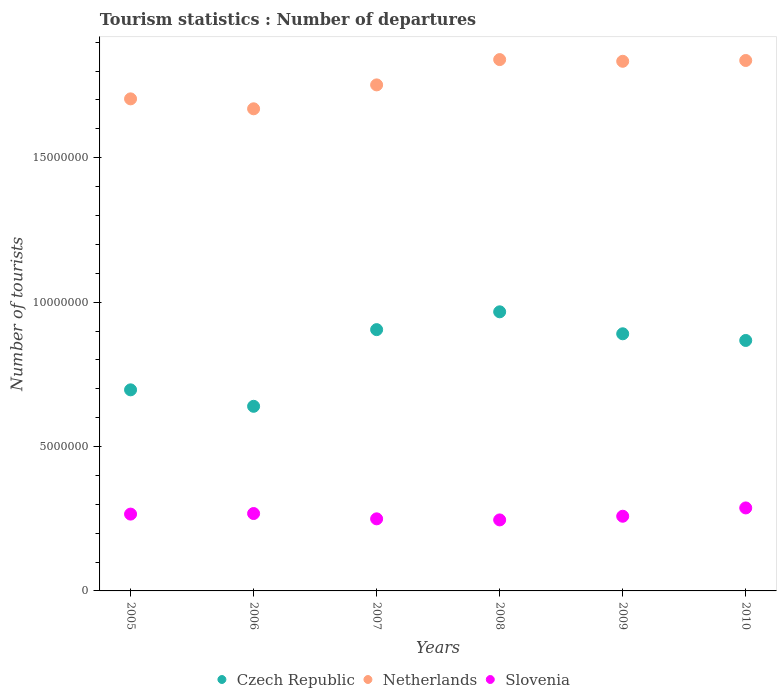How many different coloured dotlines are there?
Your response must be concise. 3. Is the number of dotlines equal to the number of legend labels?
Offer a terse response. Yes. What is the number of tourist departures in Netherlands in 2007?
Provide a succinct answer. 1.75e+07. Across all years, what is the maximum number of tourist departures in Czech Republic?
Make the answer very short. 9.66e+06. Across all years, what is the minimum number of tourist departures in Czech Republic?
Offer a terse response. 6.39e+06. In which year was the number of tourist departures in Czech Republic maximum?
Your answer should be compact. 2008. In which year was the number of tourist departures in Czech Republic minimum?
Ensure brevity in your answer.  2006. What is the total number of tourist departures in Czech Republic in the graph?
Keep it short and to the point. 4.96e+07. What is the difference between the number of tourist departures in Czech Republic in 2006 and that in 2008?
Give a very brief answer. -3.27e+06. What is the difference between the number of tourist departures in Czech Republic in 2005 and the number of tourist departures in Netherlands in 2010?
Ensure brevity in your answer.  -1.14e+07. What is the average number of tourist departures in Slovenia per year?
Your answer should be very brief. 2.63e+06. In the year 2007, what is the difference between the number of tourist departures in Netherlands and number of tourist departures in Czech Republic?
Give a very brief answer. 8.48e+06. What is the ratio of the number of tourist departures in Slovenia in 2009 to that in 2010?
Offer a very short reply. 0.9. Is the number of tourist departures in Slovenia in 2008 less than that in 2010?
Your response must be concise. Yes. Is the difference between the number of tourist departures in Netherlands in 2007 and 2010 greater than the difference between the number of tourist departures in Czech Republic in 2007 and 2010?
Your answer should be compact. No. What is the difference between the highest and the second highest number of tourist departures in Slovenia?
Keep it short and to the point. 1.94e+05. What is the difference between the highest and the lowest number of tourist departures in Czech Republic?
Provide a succinct answer. 3.27e+06. Does the number of tourist departures in Slovenia monotonically increase over the years?
Make the answer very short. No. Is the number of tourist departures in Slovenia strictly greater than the number of tourist departures in Czech Republic over the years?
Keep it short and to the point. No. Is the number of tourist departures in Netherlands strictly less than the number of tourist departures in Czech Republic over the years?
Give a very brief answer. No. How many years are there in the graph?
Ensure brevity in your answer.  6. What is the difference between two consecutive major ticks on the Y-axis?
Give a very brief answer. 5.00e+06. Where does the legend appear in the graph?
Keep it short and to the point. Bottom center. What is the title of the graph?
Provide a short and direct response. Tourism statistics : Number of departures. What is the label or title of the X-axis?
Offer a very short reply. Years. What is the label or title of the Y-axis?
Offer a very short reply. Number of tourists. What is the Number of tourists in Czech Republic in 2005?
Ensure brevity in your answer.  6.96e+06. What is the Number of tourists in Netherlands in 2005?
Offer a very short reply. 1.70e+07. What is the Number of tourists in Slovenia in 2005?
Ensure brevity in your answer.  2.66e+06. What is the Number of tourists of Czech Republic in 2006?
Provide a short and direct response. 6.39e+06. What is the Number of tourists of Netherlands in 2006?
Keep it short and to the point. 1.67e+07. What is the Number of tourists of Slovenia in 2006?
Offer a very short reply. 2.68e+06. What is the Number of tourists of Czech Republic in 2007?
Provide a short and direct response. 9.05e+06. What is the Number of tourists of Netherlands in 2007?
Ensure brevity in your answer.  1.75e+07. What is the Number of tourists of Slovenia in 2007?
Keep it short and to the point. 2.50e+06. What is the Number of tourists of Czech Republic in 2008?
Ensure brevity in your answer.  9.66e+06. What is the Number of tourists in Netherlands in 2008?
Provide a succinct answer. 1.84e+07. What is the Number of tourists in Slovenia in 2008?
Your response must be concise. 2.46e+06. What is the Number of tourists in Czech Republic in 2009?
Your answer should be compact. 8.90e+06. What is the Number of tourists in Netherlands in 2009?
Offer a very short reply. 1.83e+07. What is the Number of tourists of Slovenia in 2009?
Offer a very short reply. 2.59e+06. What is the Number of tourists of Czech Republic in 2010?
Your answer should be compact. 8.67e+06. What is the Number of tourists of Netherlands in 2010?
Offer a very short reply. 1.84e+07. What is the Number of tourists of Slovenia in 2010?
Provide a short and direct response. 2.87e+06. Across all years, what is the maximum Number of tourists of Czech Republic?
Make the answer very short. 9.66e+06. Across all years, what is the maximum Number of tourists of Netherlands?
Offer a very short reply. 1.84e+07. Across all years, what is the maximum Number of tourists of Slovenia?
Keep it short and to the point. 2.87e+06. Across all years, what is the minimum Number of tourists of Czech Republic?
Offer a very short reply. 6.39e+06. Across all years, what is the minimum Number of tourists in Netherlands?
Give a very brief answer. 1.67e+07. Across all years, what is the minimum Number of tourists in Slovenia?
Make the answer very short. 2.46e+06. What is the total Number of tourists in Czech Republic in the graph?
Your response must be concise. 4.96e+07. What is the total Number of tourists of Netherlands in the graph?
Provide a short and direct response. 1.06e+08. What is the total Number of tourists in Slovenia in the graph?
Keep it short and to the point. 1.58e+07. What is the difference between the Number of tourists in Czech Republic in 2005 and that in 2006?
Provide a succinct answer. 5.70e+05. What is the difference between the Number of tourists of Netherlands in 2005 and that in 2006?
Ensure brevity in your answer.  3.44e+05. What is the difference between the Number of tourists in Czech Republic in 2005 and that in 2007?
Your response must be concise. -2.08e+06. What is the difference between the Number of tourists of Netherlands in 2005 and that in 2007?
Offer a terse response. -4.84e+05. What is the difference between the Number of tourists of Slovenia in 2005 and that in 2007?
Make the answer very short. 1.64e+05. What is the difference between the Number of tourists in Czech Republic in 2005 and that in 2008?
Your response must be concise. -2.70e+06. What is the difference between the Number of tourists in Netherlands in 2005 and that in 2008?
Your response must be concise. -1.36e+06. What is the difference between the Number of tourists in Slovenia in 2005 and that in 2008?
Offer a terse response. 2.01e+05. What is the difference between the Number of tourists in Czech Republic in 2005 and that in 2009?
Ensure brevity in your answer.  -1.94e+06. What is the difference between the Number of tourists in Netherlands in 2005 and that in 2009?
Your answer should be very brief. -1.30e+06. What is the difference between the Number of tourists of Slovenia in 2005 and that in 2009?
Offer a terse response. 7.40e+04. What is the difference between the Number of tourists in Czech Republic in 2005 and that in 2010?
Provide a short and direct response. -1.71e+06. What is the difference between the Number of tourists of Netherlands in 2005 and that in 2010?
Keep it short and to the point. -1.33e+06. What is the difference between the Number of tourists in Slovenia in 2005 and that in 2010?
Provide a short and direct response. -2.14e+05. What is the difference between the Number of tourists of Czech Republic in 2006 and that in 2007?
Ensure brevity in your answer.  -2.66e+06. What is the difference between the Number of tourists in Netherlands in 2006 and that in 2007?
Keep it short and to the point. -8.28e+05. What is the difference between the Number of tourists of Slovenia in 2006 and that in 2007?
Give a very brief answer. 1.84e+05. What is the difference between the Number of tourists of Czech Republic in 2006 and that in 2008?
Offer a very short reply. -3.27e+06. What is the difference between the Number of tourists of Netherlands in 2006 and that in 2008?
Your answer should be compact. -1.70e+06. What is the difference between the Number of tourists in Slovenia in 2006 and that in 2008?
Keep it short and to the point. 2.21e+05. What is the difference between the Number of tourists of Czech Republic in 2006 and that in 2009?
Your answer should be very brief. -2.51e+06. What is the difference between the Number of tourists in Netherlands in 2006 and that in 2009?
Ensure brevity in your answer.  -1.64e+06. What is the difference between the Number of tourists of Slovenia in 2006 and that in 2009?
Ensure brevity in your answer.  9.40e+04. What is the difference between the Number of tourists of Czech Republic in 2006 and that in 2010?
Your answer should be compact. -2.28e+06. What is the difference between the Number of tourists in Netherlands in 2006 and that in 2010?
Keep it short and to the point. -1.67e+06. What is the difference between the Number of tourists in Slovenia in 2006 and that in 2010?
Offer a terse response. -1.94e+05. What is the difference between the Number of tourists of Czech Republic in 2007 and that in 2008?
Offer a terse response. -6.17e+05. What is the difference between the Number of tourists of Netherlands in 2007 and that in 2008?
Make the answer very short. -8.76e+05. What is the difference between the Number of tourists of Slovenia in 2007 and that in 2008?
Your answer should be very brief. 3.70e+04. What is the difference between the Number of tourists in Czech Republic in 2007 and that in 2009?
Ensure brevity in your answer.  1.44e+05. What is the difference between the Number of tourists of Netherlands in 2007 and that in 2009?
Your response must be concise. -8.17e+05. What is the difference between the Number of tourists of Czech Republic in 2007 and that in 2010?
Ensure brevity in your answer.  3.75e+05. What is the difference between the Number of tourists of Netherlands in 2007 and that in 2010?
Offer a very short reply. -8.45e+05. What is the difference between the Number of tourists in Slovenia in 2007 and that in 2010?
Give a very brief answer. -3.78e+05. What is the difference between the Number of tourists in Czech Republic in 2008 and that in 2009?
Provide a short and direct response. 7.61e+05. What is the difference between the Number of tourists of Netherlands in 2008 and that in 2009?
Provide a succinct answer. 5.90e+04. What is the difference between the Number of tourists in Slovenia in 2008 and that in 2009?
Offer a very short reply. -1.27e+05. What is the difference between the Number of tourists of Czech Republic in 2008 and that in 2010?
Keep it short and to the point. 9.92e+05. What is the difference between the Number of tourists of Netherlands in 2008 and that in 2010?
Provide a succinct answer. 3.10e+04. What is the difference between the Number of tourists in Slovenia in 2008 and that in 2010?
Provide a succinct answer. -4.15e+05. What is the difference between the Number of tourists in Czech Republic in 2009 and that in 2010?
Give a very brief answer. 2.31e+05. What is the difference between the Number of tourists in Netherlands in 2009 and that in 2010?
Your answer should be compact. -2.80e+04. What is the difference between the Number of tourists of Slovenia in 2009 and that in 2010?
Your answer should be very brief. -2.88e+05. What is the difference between the Number of tourists in Czech Republic in 2005 and the Number of tourists in Netherlands in 2006?
Provide a short and direct response. -9.73e+06. What is the difference between the Number of tourists in Czech Republic in 2005 and the Number of tourists in Slovenia in 2006?
Your response must be concise. 4.28e+06. What is the difference between the Number of tourists in Netherlands in 2005 and the Number of tourists in Slovenia in 2006?
Keep it short and to the point. 1.44e+07. What is the difference between the Number of tourists in Czech Republic in 2005 and the Number of tourists in Netherlands in 2007?
Your response must be concise. -1.06e+07. What is the difference between the Number of tourists in Czech Republic in 2005 and the Number of tourists in Slovenia in 2007?
Keep it short and to the point. 4.47e+06. What is the difference between the Number of tourists of Netherlands in 2005 and the Number of tourists of Slovenia in 2007?
Your answer should be very brief. 1.45e+07. What is the difference between the Number of tourists of Czech Republic in 2005 and the Number of tourists of Netherlands in 2008?
Offer a terse response. -1.14e+07. What is the difference between the Number of tourists of Czech Republic in 2005 and the Number of tourists of Slovenia in 2008?
Your response must be concise. 4.50e+06. What is the difference between the Number of tourists in Netherlands in 2005 and the Number of tourists in Slovenia in 2008?
Your answer should be compact. 1.46e+07. What is the difference between the Number of tourists of Czech Republic in 2005 and the Number of tourists of Netherlands in 2009?
Your answer should be very brief. -1.14e+07. What is the difference between the Number of tourists in Czech Republic in 2005 and the Number of tourists in Slovenia in 2009?
Provide a succinct answer. 4.38e+06. What is the difference between the Number of tourists of Netherlands in 2005 and the Number of tourists of Slovenia in 2009?
Offer a very short reply. 1.45e+07. What is the difference between the Number of tourists in Czech Republic in 2005 and the Number of tourists in Netherlands in 2010?
Your response must be concise. -1.14e+07. What is the difference between the Number of tourists of Czech Republic in 2005 and the Number of tourists of Slovenia in 2010?
Provide a short and direct response. 4.09e+06. What is the difference between the Number of tourists in Netherlands in 2005 and the Number of tourists in Slovenia in 2010?
Keep it short and to the point. 1.42e+07. What is the difference between the Number of tourists of Czech Republic in 2006 and the Number of tourists of Netherlands in 2007?
Your response must be concise. -1.11e+07. What is the difference between the Number of tourists of Czech Republic in 2006 and the Number of tourists of Slovenia in 2007?
Offer a terse response. 3.90e+06. What is the difference between the Number of tourists in Netherlands in 2006 and the Number of tourists in Slovenia in 2007?
Offer a terse response. 1.42e+07. What is the difference between the Number of tourists in Czech Republic in 2006 and the Number of tourists in Netherlands in 2008?
Keep it short and to the point. -1.20e+07. What is the difference between the Number of tourists of Czech Republic in 2006 and the Number of tourists of Slovenia in 2008?
Give a very brief answer. 3.93e+06. What is the difference between the Number of tourists in Netherlands in 2006 and the Number of tourists in Slovenia in 2008?
Make the answer very short. 1.42e+07. What is the difference between the Number of tourists in Czech Republic in 2006 and the Number of tourists in Netherlands in 2009?
Give a very brief answer. -1.19e+07. What is the difference between the Number of tourists of Czech Republic in 2006 and the Number of tourists of Slovenia in 2009?
Your answer should be very brief. 3.81e+06. What is the difference between the Number of tourists in Netherlands in 2006 and the Number of tourists in Slovenia in 2009?
Your response must be concise. 1.41e+07. What is the difference between the Number of tourists of Czech Republic in 2006 and the Number of tourists of Netherlands in 2010?
Offer a terse response. -1.20e+07. What is the difference between the Number of tourists of Czech Republic in 2006 and the Number of tourists of Slovenia in 2010?
Your answer should be compact. 3.52e+06. What is the difference between the Number of tourists of Netherlands in 2006 and the Number of tourists of Slovenia in 2010?
Give a very brief answer. 1.38e+07. What is the difference between the Number of tourists of Czech Republic in 2007 and the Number of tourists of Netherlands in 2008?
Ensure brevity in your answer.  -9.35e+06. What is the difference between the Number of tourists in Czech Republic in 2007 and the Number of tourists in Slovenia in 2008?
Give a very brief answer. 6.59e+06. What is the difference between the Number of tourists in Netherlands in 2007 and the Number of tourists in Slovenia in 2008?
Make the answer very short. 1.51e+07. What is the difference between the Number of tourists in Czech Republic in 2007 and the Number of tourists in Netherlands in 2009?
Ensure brevity in your answer.  -9.29e+06. What is the difference between the Number of tourists in Czech Republic in 2007 and the Number of tourists in Slovenia in 2009?
Make the answer very short. 6.46e+06. What is the difference between the Number of tourists of Netherlands in 2007 and the Number of tourists of Slovenia in 2009?
Ensure brevity in your answer.  1.49e+07. What is the difference between the Number of tourists in Czech Republic in 2007 and the Number of tourists in Netherlands in 2010?
Your answer should be very brief. -9.32e+06. What is the difference between the Number of tourists in Czech Republic in 2007 and the Number of tourists in Slovenia in 2010?
Your answer should be compact. 6.17e+06. What is the difference between the Number of tourists of Netherlands in 2007 and the Number of tourists of Slovenia in 2010?
Ensure brevity in your answer.  1.46e+07. What is the difference between the Number of tourists of Czech Republic in 2008 and the Number of tourists of Netherlands in 2009?
Ensure brevity in your answer.  -8.68e+06. What is the difference between the Number of tourists of Czech Republic in 2008 and the Number of tourists of Slovenia in 2009?
Make the answer very short. 7.08e+06. What is the difference between the Number of tourists of Netherlands in 2008 and the Number of tourists of Slovenia in 2009?
Your response must be concise. 1.58e+07. What is the difference between the Number of tourists of Czech Republic in 2008 and the Number of tourists of Netherlands in 2010?
Your response must be concise. -8.70e+06. What is the difference between the Number of tourists of Czech Republic in 2008 and the Number of tourists of Slovenia in 2010?
Provide a short and direct response. 6.79e+06. What is the difference between the Number of tourists of Netherlands in 2008 and the Number of tourists of Slovenia in 2010?
Make the answer very short. 1.55e+07. What is the difference between the Number of tourists in Czech Republic in 2009 and the Number of tourists in Netherlands in 2010?
Give a very brief answer. -9.46e+06. What is the difference between the Number of tourists in Czech Republic in 2009 and the Number of tourists in Slovenia in 2010?
Keep it short and to the point. 6.03e+06. What is the difference between the Number of tourists in Netherlands in 2009 and the Number of tourists in Slovenia in 2010?
Make the answer very short. 1.55e+07. What is the average Number of tourists of Czech Republic per year?
Make the answer very short. 8.27e+06. What is the average Number of tourists of Netherlands per year?
Provide a short and direct response. 1.77e+07. What is the average Number of tourists in Slovenia per year?
Provide a succinct answer. 2.63e+06. In the year 2005, what is the difference between the Number of tourists of Czech Republic and Number of tourists of Netherlands?
Provide a succinct answer. -1.01e+07. In the year 2005, what is the difference between the Number of tourists in Czech Republic and Number of tourists in Slovenia?
Your answer should be compact. 4.30e+06. In the year 2005, what is the difference between the Number of tourists of Netherlands and Number of tourists of Slovenia?
Keep it short and to the point. 1.44e+07. In the year 2006, what is the difference between the Number of tourists of Czech Republic and Number of tourists of Netherlands?
Offer a terse response. -1.03e+07. In the year 2006, what is the difference between the Number of tourists of Czech Republic and Number of tourists of Slovenia?
Your answer should be compact. 3.71e+06. In the year 2006, what is the difference between the Number of tourists in Netherlands and Number of tourists in Slovenia?
Keep it short and to the point. 1.40e+07. In the year 2007, what is the difference between the Number of tourists in Czech Republic and Number of tourists in Netherlands?
Provide a succinct answer. -8.48e+06. In the year 2007, what is the difference between the Number of tourists of Czech Republic and Number of tourists of Slovenia?
Keep it short and to the point. 6.55e+06. In the year 2007, what is the difference between the Number of tourists of Netherlands and Number of tourists of Slovenia?
Provide a succinct answer. 1.50e+07. In the year 2008, what is the difference between the Number of tourists of Czech Republic and Number of tourists of Netherlands?
Provide a succinct answer. -8.73e+06. In the year 2008, what is the difference between the Number of tourists in Czech Republic and Number of tourists in Slovenia?
Keep it short and to the point. 7.21e+06. In the year 2008, what is the difference between the Number of tourists of Netherlands and Number of tourists of Slovenia?
Provide a short and direct response. 1.59e+07. In the year 2009, what is the difference between the Number of tourists in Czech Republic and Number of tourists in Netherlands?
Provide a short and direct response. -9.44e+06. In the year 2009, what is the difference between the Number of tourists of Czech Republic and Number of tourists of Slovenia?
Your answer should be very brief. 6.32e+06. In the year 2009, what is the difference between the Number of tourists in Netherlands and Number of tourists in Slovenia?
Make the answer very short. 1.58e+07. In the year 2010, what is the difference between the Number of tourists of Czech Republic and Number of tourists of Netherlands?
Provide a succinct answer. -9.70e+06. In the year 2010, what is the difference between the Number of tourists in Czech Republic and Number of tourists in Slovenia?
Give a very brief answer. 5.80e+06. In the year 2010, what is the difference between the Number of tourists of Netherlands and Number of tourists of Slovenia?
Your answer should be very brief. 1.55e+07. What is the ratio of the Number of tourists of Czech Republic in 2005 to that in 2006?
Your answer should be compact. 1.09. What is the ratio of the Number of tourists of Netherlands in 2005 to that in 2006?
Your response must be concise. 1.02. What is the ratio of the Number of tourists in Slovenia in 2005 to that in 2006?
Your response must be concise. 0.99. What is the ratio of the Number of tourists of Czech Republic in 2005 to that in 2007?
Provide a short and direct response. 0.77. What is the ratio of the Number of tourists of Netherlands in 2005 to that in 2007?
Provide a succinct answer. 0.97. What is the ratio of the Number of tourists in Slovenia in 2005 to that in 2007?
Ensure brevity in your answer.  1.07. What is the ratio of the Number of tourists in Czech Republic in 2005 to that in 2008?
Make the answer very short. 0.72. What is the ratio of the Number of tourists of Netherlands in 2005 to that in 2008?
Your answer should be compact. 0.93. What is the ratio of the Number of tourists in Slovenia in 2005 to that in 2008?
Offer a terse response. 1.08. What is the ratio of the Number of tourists in Czech Republic in 2005 to that in 2009?
Provide a short and direct response. 0.78. What is the ratio of the Number of tourists in Netherlands in 2005 to that in 2009?
Make the answer very short. 0.93. What is the ratio of the Number of tourists of Slovenia in 2005 to that in 2009?
Your response must be concise. 1.03. What is the ratio of the Number of tourists in Czech Republic in 2005 to that in 2010?
Your response must be concise. 0.8. What is the ratio of the Number of tourists in Netherlands in 2005 to that in 2010?
Make the answer very short. 0.93. What is the ratio of the Number of tourists of Slovenia in 2005 to that in 2010?
Your response must be concise. 0.93. What is the ratio of the Number of tourists of Czech Republic in 2006 to that in 2007?
Your answer should be compact. 0.71. What is the ratio of the Number of tourists in Netherlands in 2006 to that in 2007?
Make the answer very short. 0.95. What is the ratio of the Number of tourists of Slovenia in 2006 to that in 2007?
Provide a succinct answer. 1.07. What is the ratio of the Number of tourists in Czech Republic in 2006 to that in 2008?
Provide a short and direct response. 0.66. What is the ratio of the Number of tourists of Netherlands in 2006 to that in 2008?
Keep it short and to the point. 0.91. What is the ratio of the Number of tourists of Slovenia in 2006 to that in 2008?
Offer a terse response. 1.09. What is the ratio of the Number of tourists of Czech Republic in 2006 to that in 2009?
Your response must be concise. 0.72. What is the ratio of the Number of tourists of Netherlands in 2006 to that in 2009?
Your answer should be compact. 0.91. What is the ratio of the Number of tourists in Slovenia in 2006 to that in 2009?
Make the answer very short. 1.04. What is the ratio of the Number of tourists in Czech Republic in 2006 to that in 2010?
Your response must be concise. 0.74. What is the ratio of the Number of tourists in Netherlands in 2006 to that in 2010?
Your answer should be compact. 0.91. What is the ratio of the Number of tourists in Slovenia in 2006 to that in 2010?
Offer a terse response. 0.93. What is the ratio of the Number of tourists in Czech Republic in 2007 to that in 2008?
Provide a short and direct response. 0.94. What is the ratio of the Number of tourists of Netherlands in 2007 to that in 2008?
Your answer should be very brief. 0.95. What is the ratio of the Number of tourists of Czech Republic in 2007 to that in 2009?
Your answer should be compact. 1.02. What is the ratio of the Number of tourists in Netherlands in 2007 to that in 2009?
Give a very brief answer. 0.96. What is the ratio of the Number of tourists in Slovenia in 2007 to that in 2009?
Make the answer very short. 0.97. What is the ratio of the Number of tourists in Czech Republic in 2007 to that in 2010?
Your answer should be compact. 1.04. What is the ratio of the Number of tourists in Netherlands in 2007 to that in 2010?
Your response must be concise. 0.95. What is the ratio of the Number of tourists of Slovenia in 2007 to that in 2010?
Offer a very short reply. 0.87. What is the ratio of the Number of tourists in Czech Republic in 2008 to that in 2009?
Offer a very short reply. 1.09. What is the ratio of the Number of tourists in Netherlands in 2008 to that in 2009?
Provide a succinct answer. 1. What is the ratio of the Number of tourists of Slovenia in 2008 to that in 2009?
Make the answer very short. 0.95. What is the ratio of the Number of tourists in Czech Republic in 2008 to that in 2010?
Give a very brief answer. 1.11. What is the ratio of the Number of tourists in Netherlands in 2008 to that in 2010?
Provide a short and direct response. 1. What is the ratio of the Number of tourists in Slovenia in 2008 to that in 2010?
Provide a succinct answer. 0.86. What is the ratio of the Number of tourists of Czech Republic in 2009 to that in 2010?
Offer a very short reply. 1.03. What is the ratio of the Number of tourists of Netherlands in 2009 to that in 2010?
Your answer should be compact. 1. What is the ratio of the Number of tourists of Slovenia in 2009 to that in 2010?
Give a very brief answer. 0.9. What is the difference between the highest and the second highest Number of tourists in Czech Republic?
Offer a terse response. 6.17e+05. What is the difference between the highest and the second highest Number of tourists of Netherlands?
Give a very brief answer. 3.10e+04. What is the difference between the highest and the second highest Number of tourists in Slovenia?
Your response must be concise. 1.94e+05. What is the difference between the highest and the lowest Number of tourists of Czech Republic?
Provide a succinct answer. 3.27e+06. What is the difference between the highest and the lowest Number of tourists in Netherlands?
Give a very brief answer. 1.70e+06. What is the difference between the highest and the lowest Number of tourists in Slovenia?
Your answer should be compact. 4.15e+05. 